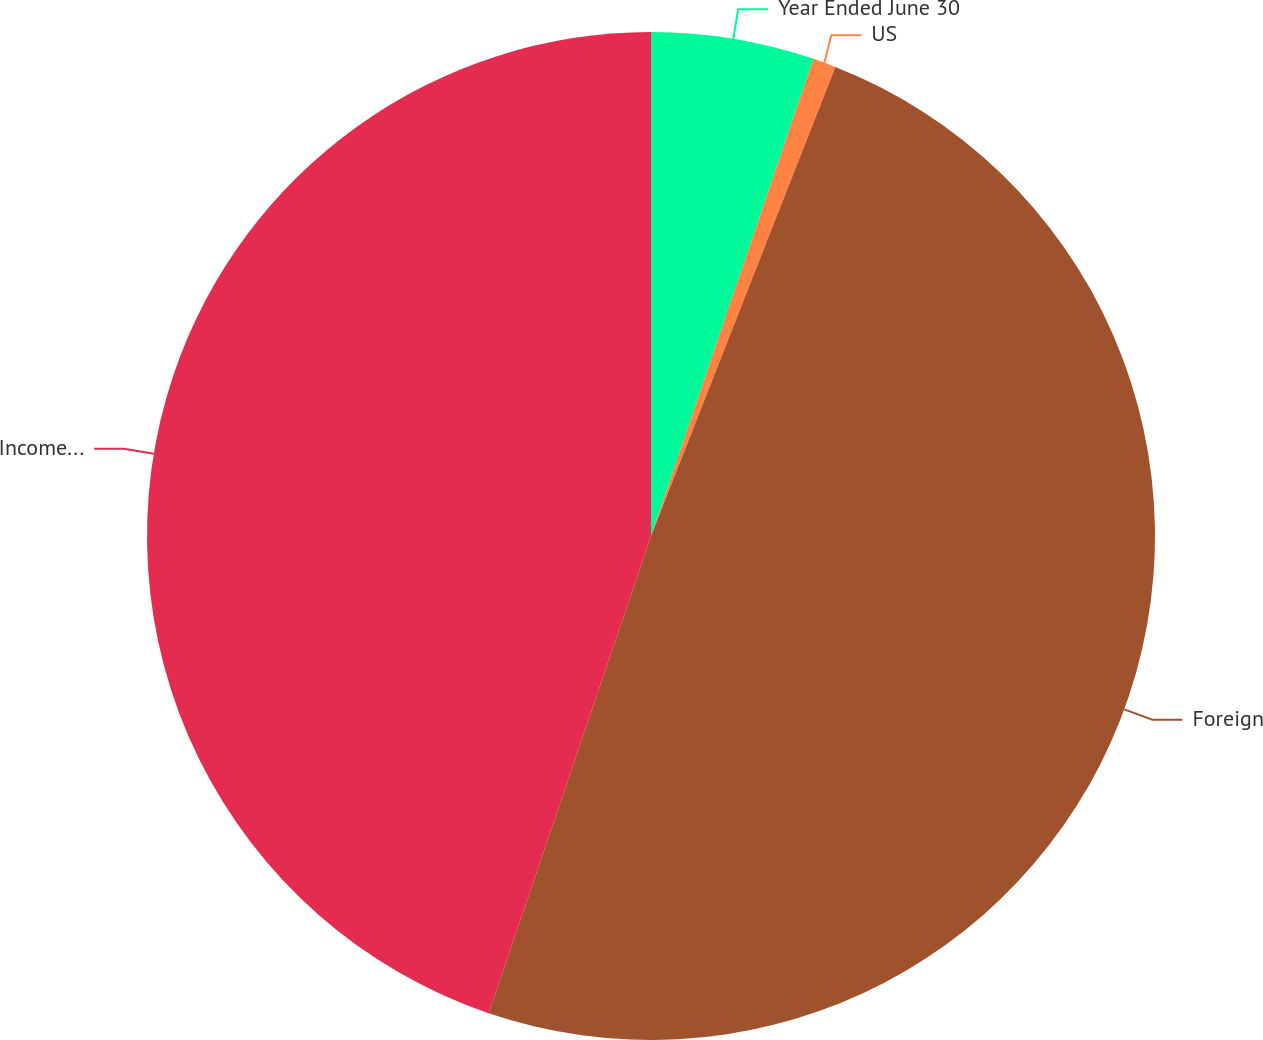<chart> <loc_0><loc_0><loc_500><loc_500><pie_chart><fcel>Year Ended June 30<fcel>US<fcel>Foreign<fcel>Income before income taxes<nl><fcel>5.22%<fcel>0.74%<fcel>49.26%<fcel>44.78%<nl></chart> 